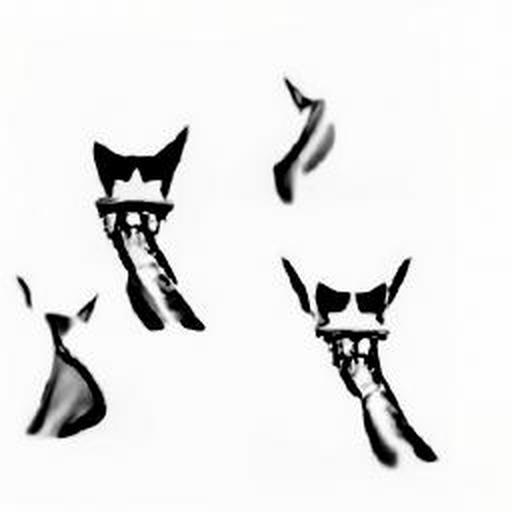Could this image be part of a larger series or narrative? While it's impossible to determine from the image alone, the stylized and abstract nature of the subjects suggests that it could indeed be part of a larger artistic series or visual narrative, exploring themes such as identity, transformation, or the nature of perception. 